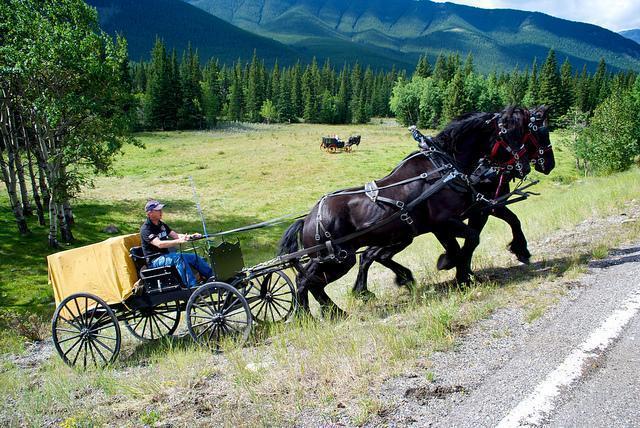How many horses are in the picture?
Give a very brief answer. 2. How many cups are there?
Give a very brief answer. 0. 